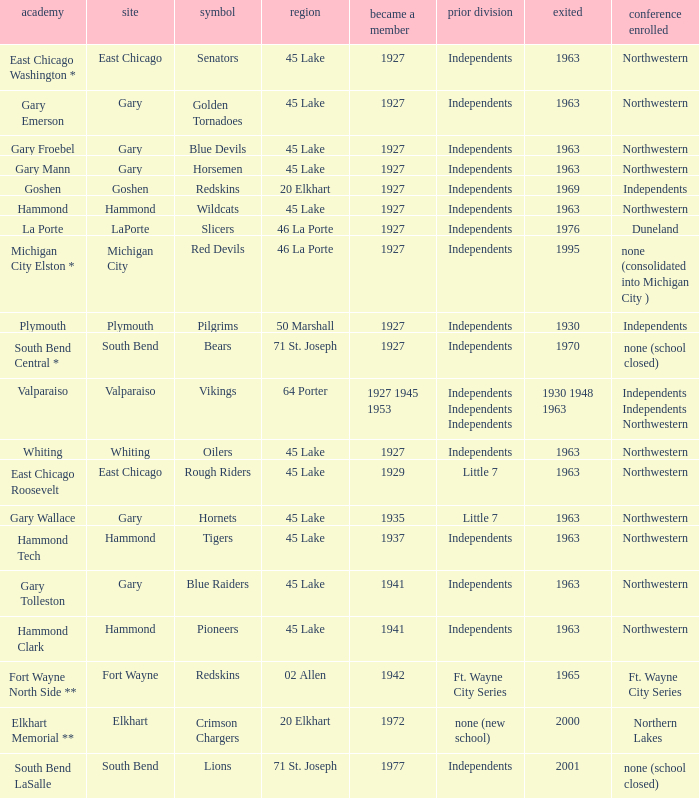At what times does the blue devils mascot appear in gary froebel school? 1927.0. 